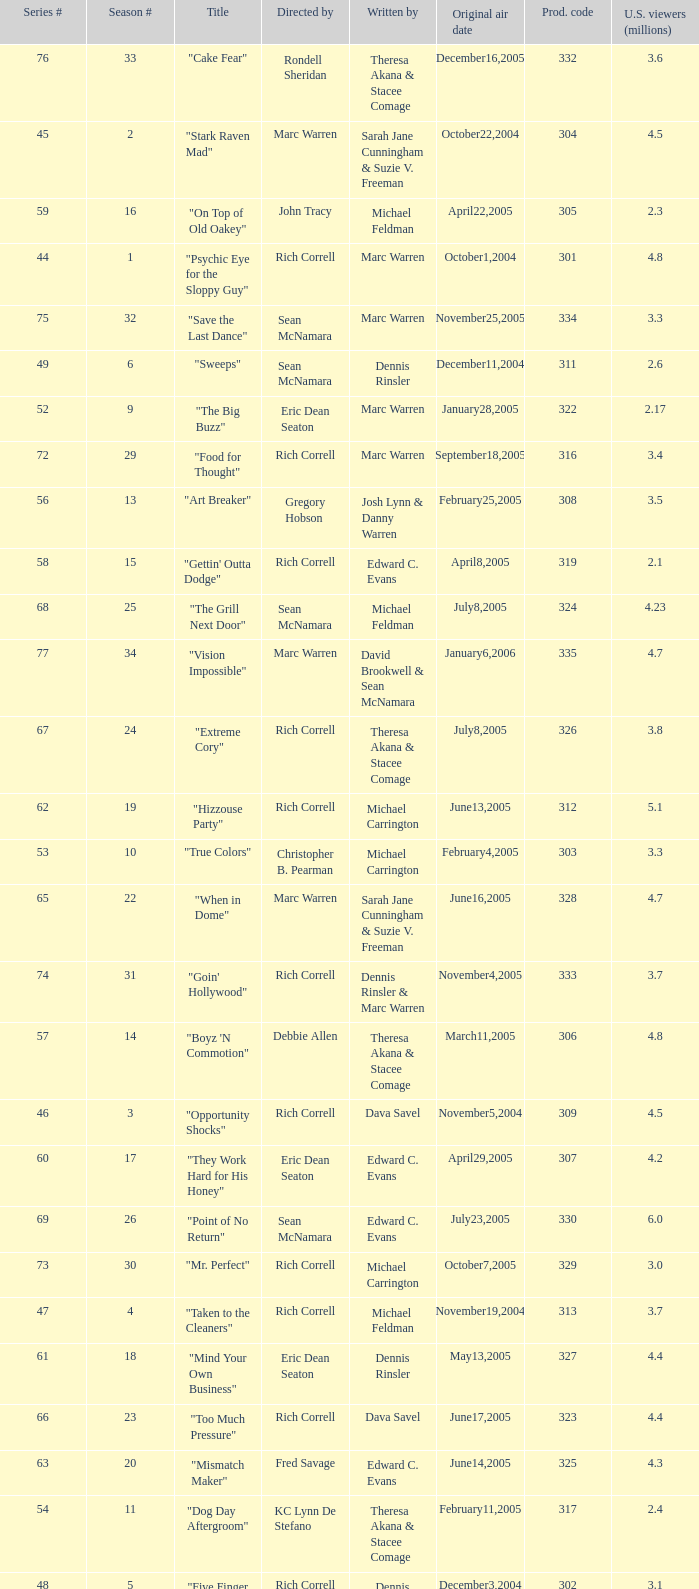What number episode in the season had a production code of 334? 32.0. 